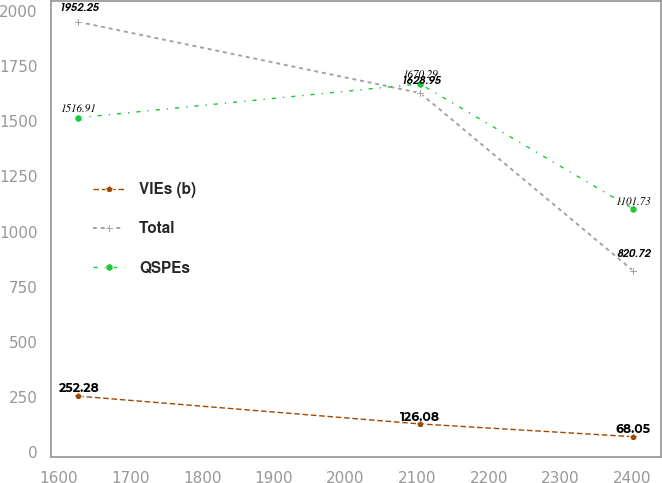<chart> <loc_0><loc_0><loc_500><loc_500><line_chart><ecel><fcel>VIEs (b)<fcel>Total<fcel>QSPEs<nl><fcel>1627.02<fcel>252.28<fcel>1952.25<fcel>1516.91<nl><fcel>2104.23<fcel>126.08<fcel>1628.95<fcel>1670.29<nl><fcel>2402.08<fcel>68.05<fcel>820.72<fcel>1101.73<nl></chart> 